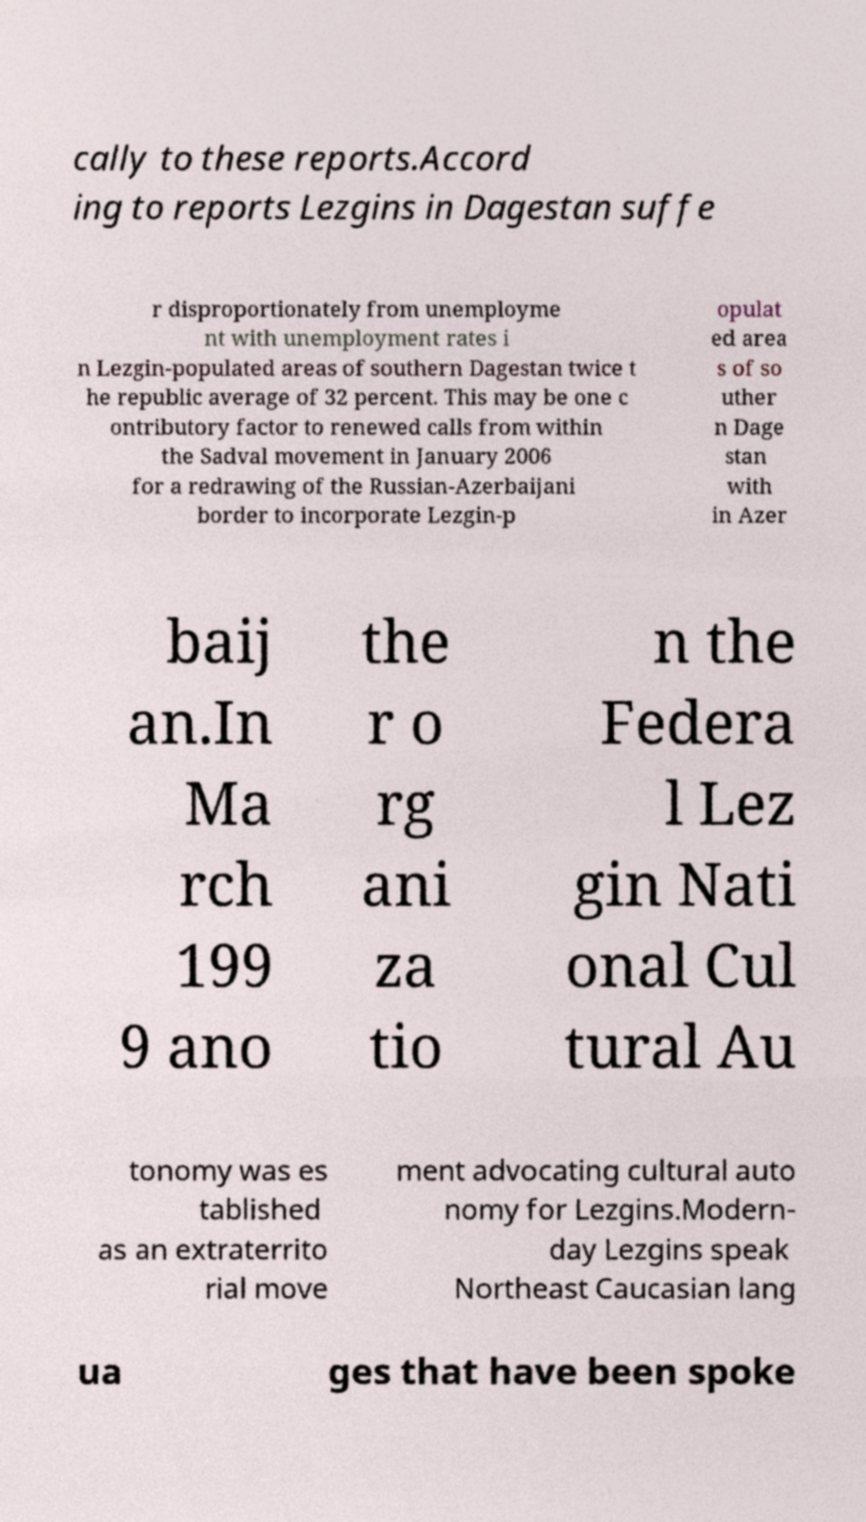Could you extract and type out the text from this image? cally to these reports.Accord ing to reports Lezgins in Dagestan suffe r disproportionately from unemployme nt with unemployment rates i n Lezgin-populated areas of southern Dagestan twice t he republic average of 32 percent. This may be one c ontributory factor to renewed calls from within the Sadval movement in January 2006 for a redrawing of the Russian-Azerbaijani border to incorporate Lezgin-p opulat ed area s of so uther n Dage stan with in Azer baij an.In Ma rch 199 9 ano the r o rg ani za tio n the Federa l Lez gin Nati onal Cul tural Au tonomy was es tablished as an extraterrito rial move ment advocating cultural auto nomy for Lezgins.Modern- day Lezgins speak Northeast Caucasian lang ua ges that have been spoke 